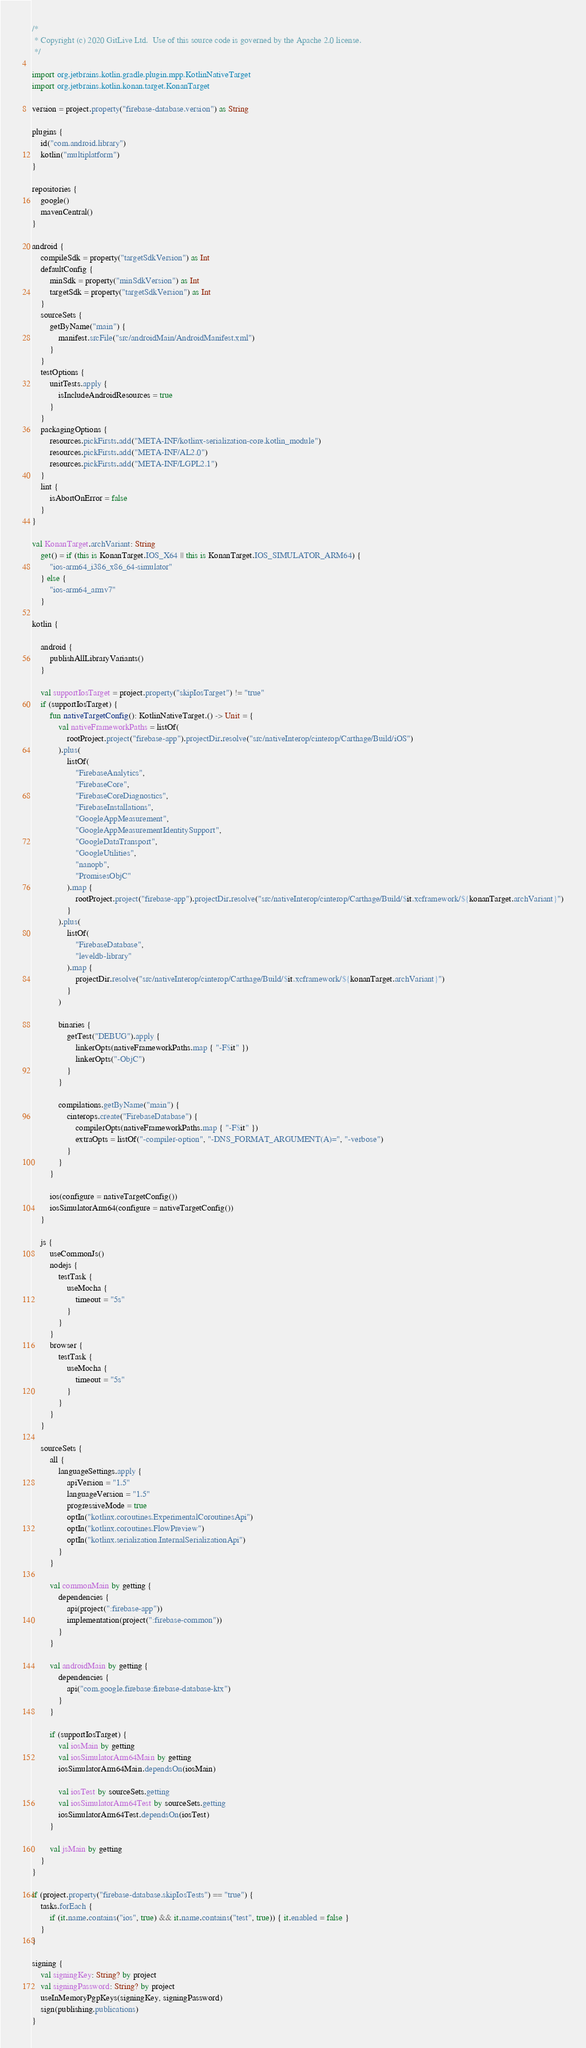Convert code to text. <code><loc_0><loc_0><loc_500><loc_500><_Kotlin_>/*
 * Copyright (c) 2020 GitLive Ltd.  Use of this source code is governed by the Apache 2.0 license.
 */

import org.jetbrains.kotlin.gradle.plugin.mpp.KotlinNativeTarget
import org.jetbrains.kotlin.konan.target.KonanTarget

version = project.property("firebase-database.version") as String

plugins {
    id("com.android.library")
    kotlin("multiplatform")
}

repositories {
    google()
    mavenCentral()
}

android {
    compileSdk = property("targetSdkVersion") as Int
    defaultConfig {
        minSdk = property("minSdkVersion") as Int
        targetSdk = property("targetSdkVersion") as Int
    }
    sourceSets {
        getByName("main") {
            manifest.srcFile("src/androidMain/AndroidManifest.xml")
        }
    }
    testOptions {
        unitTests.apply {
            isIncludeAndroidResources = true
        }
    }
    packagingOptions {
        resources.pickFirsts.add("META-INF/kotlinx-serialization-core.kotlin_module")
        resources.pickFirsts.add("META-INF/AL2.0")
        resources.pickFirsts.add("META-INF/LGPL2.1")
    }
    lint {
        isAbortOnError = false
    }
}

val KonanTarget.archVariant: String
    get() = if (this is KonanTarget.IOS_X64 || this is KonanTarget.IOS_SIMULATOR_ARM64) {
        "ios-arm64_i386_x86_64-simulator"
    } else {
        "ios-arm64_armv7"
    }

kotlin {

    android {
        publishAllLibraryVariants()
    }

    val supportIosTarget = project.property("skipIosTarget") != "true"
    if (supportIosTarget) {
        fun nativeTargetConfig(): KotlinNativeTarget.() -> Unit = {
            val nativeFrameworkPaths = listOf(
                rootProject.project("firebase-app").projectDir.resolve("src/nativeInterop/cinterop/Carthage/Build/iOS")
            ).plus(
                listOf(
                    "FirebaseAnalytics",
                    "FirebaseCore",
                    "FirebaseCoreDiagnostics",
                    "FirebaseInstallations",
                    "GoogleAppMeasurement",
                    "GoogleAppMeasurementIdentitySupport",
                    "GoogleDataTransport",
                    "GoogleUtilities",
                    "nanopb",
                    "PromisesObjC"
                ).map {
                    rootProject.project("firebase-app").projectDir.resolve("src/nativeInterop/cinterop/Carthage/Build/$it.xcframework/${konanTarget.archVariant}")
                }
            ).plus(
                listOf(
                    "FirebaseDatabase",
                    "leveldb-library"
                ).map {
                    projectDir.resolve("src/nativeInterop/cinterop/Carthage/Build/$it.xcframework/${konanTarget.archVariant}")
                }
            )

            binaries {
                getTest("DEBUG").apply {
                    linkerOpts(nativeFrameworkPaths.map { "-F$it" })
                    linkerOpts("-ObjC")
                }
            }

            compilations.getByName("main") {
                cinterops.create("FirebaseDatabase") {
                    compilerOpts(nativeFrameworkPaths.map { "-F$it" })
                    extraOpts = listOf("-compiler-option", "-DNS_FORMAT_ARGUMENT(A)=", "-verbose")
                }
            }
        }

        ios(configure = nativeTargetConfig())
        iosSimulatorArm64(configure = nativeTargetConfig())
    }

    js {
        useCommonJs()
        nodejs {
            testTask {
                useMocha {
                    timeout = "5s"
                }
            }
        }
        browser {
            testTask {
                useMocha {
                    timeout = "5s"
                }
            }
        }
    }

    sourceSets {
        all {
            languageSettings.apply {
                apiVersion = "1.5"
                languageVersion = "1.5"
                progressiveMode = true
                optIn("kotlinx.coroutines.ExperimentalCoroutinesApi")
                optIn("kotlinx.coroutines.FlowPreview")
                optIn("kotlinx.serialization.InternalSerializationApi")
            }
        }

        val commonMain by getting {
            dependencies {
                api(project(":firebase-app"))
                implementation(project(":firebase-common"))
            }
        }

        val androidMain by getting {
            dependencies {
                api("com.google.firebase:firebase-database-ktx")
            }
        }

        if (supportIosTarget) {
            val iosMain by getting
            val iosSimulatorArm64Main by getting
            iosSimulatorArm64Main.dependsOn(iosMain)

            val iosTest by sourceSets.getting
            val iosSimulatorArm64Test by sourceSets.getting
            iosSimulatorArm64Test.dependsOn(iosTest)
        }

        val jsMain by getting
    }
}

if (project.property("firebase-database.skipIosTests") == "true") {
    tasks.forEach {
        if (it.name.contains("ios", true) && it.name.contains("test", true)) { it.enabled = false }
    }
}

signing {
    val signingKey: String? by project
    val signingPassword: String? by project
    useInMemoryPgpKeys(signingKey, signingPassword)
    sign(publishing.publications)
}

</code> 